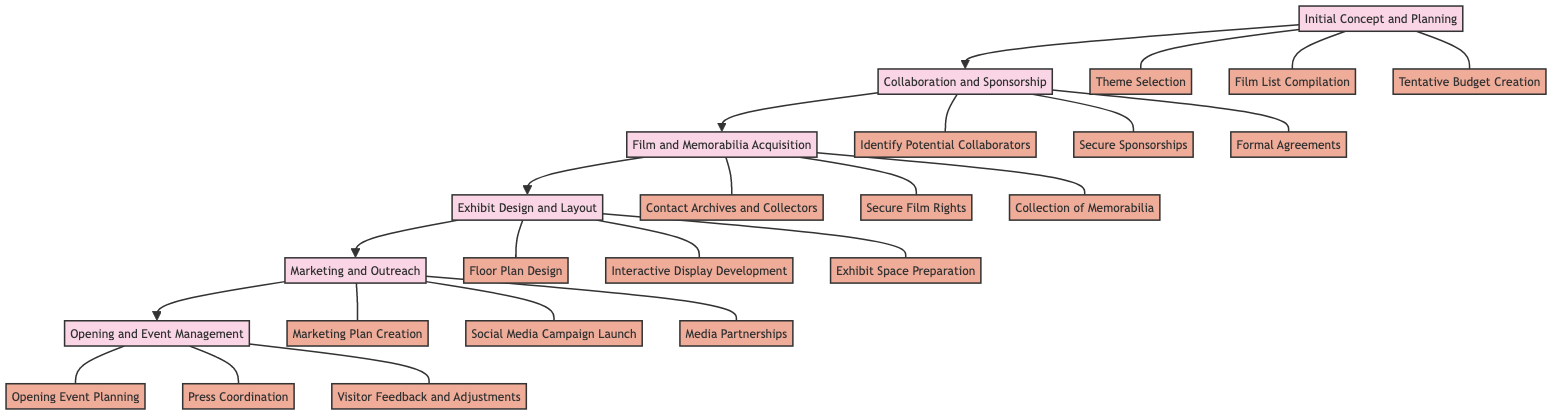What is the first step in the exhibit curation process? The diagram indicates that the first step is "Initial Concept and Planning," which is the first node in the flowchart.
Answer: Initial Concept and Planning What is the last step in the process? According to the flowchart, the last step is "Opening and Event Management," which is the final node leading to the outcome of the exhibit.
Answer: Opening and Event Management How many key milestones are listed under "Collaboration and Sponsorship"? By reviewing the flowchart, there are three key milestones listed under the "Collaboration and Sponsorship" step: "Identify Potential Collaborators," "Secure Sponsorships," and "Formal Agreements."
Answer: 3 Which step follows "Film and Memorabilia Acquisition"? The diagram shows that "Exhibit Design and Layout" directly follows the "Film and Memorabilia Acquisition" step, indicating the sequence in the curation process.
Answer: Exhibit Design and Layout What are the milestones associated with "Exhibit Design and Layout"? The flowchart presents three milestones under this step: "Floor Plan Design," "Interactive Display Development," and "Exhibit Space Preparation."
Answer: Floor Plan Design, Interactive Display Development, Exhibit Space Preparation Which major step comes before "Marketing and Outreach"? By tracing the flowchart, it can be seen that "Exhibit Design and Layout" is the step that comes immediately before "Marketing and Outreach."
Answer: Exhibit Design and Layout What is one of the milestones associated with "Initial Concept and Planning"? Among the milestones listed under "Initial Concept and Planning," "Theme Selection" is one of them, denoting a significant initial task.
Answer: Theme Selection How many main steps are involved in the curation process? The flowchart presents a total of six main steps in the curation process, each represented by distinct nodes in the diagram.
Answer: 6 What is the relationship between "Marketing and Outreach" and "Opening and Event Management"? The relationship between these two steps is sequential; "Marketing and Outreach" precedes "Opening and Event Management" in the order of the exhibit curation process as indicated by the arrows in the flowchart.
Answer: Sequential 